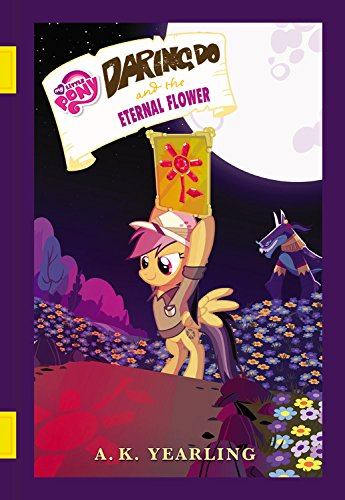Can you tell me more about the main character on the cover? Certainly! The main character on the cover is Daring Do, a daring pegasus adventurer from the My Little Pony universe. She's portrayed as brave and adventurous, often embarking on Indiana Jones-style expeditions. What's the significance of the flower she's holding? The flower holds a significant place in this story. It's the Eternal Flower, which is likely a key element in Daring Do's latest adventure as hinted by the book's title. 